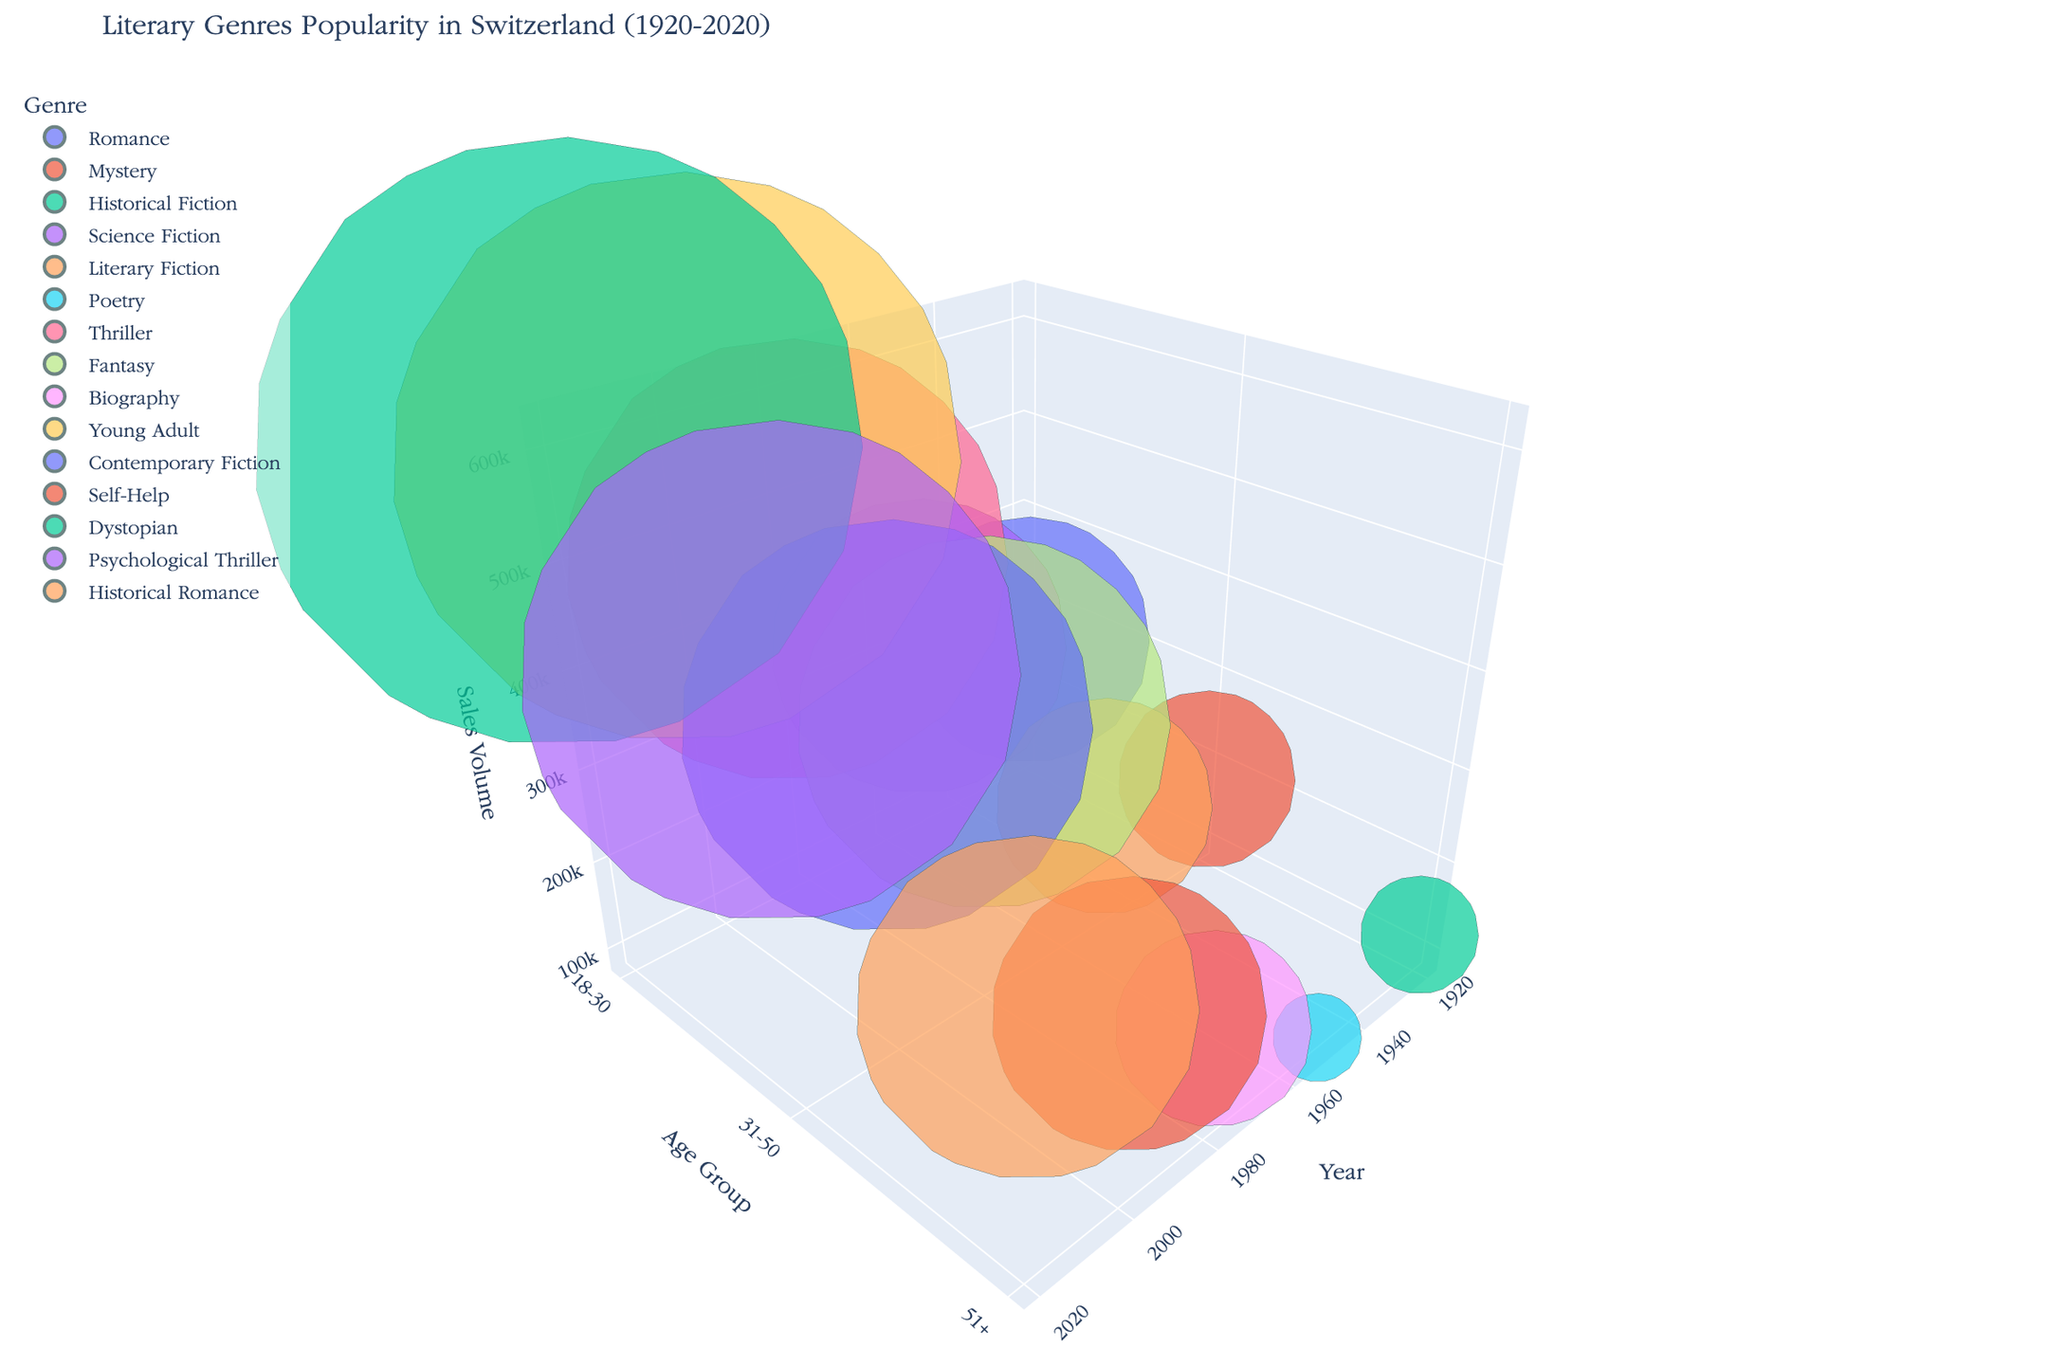what is the title of the chart? The title of the chart is usually displayed at the top of the figure. Reading it from the top of the plot shows "Literary Genres Popularity in Switzerland (1920-2020)".
Answer: Literary Genres Popularity in Switzerland (1920-2020) Which genre has the highest sales volume in the year 1920? Look at the x-axis for the year 1920 and compare the sizes of the bubbles to determine the largest one. The largest bubble in 1920 represents the genre "Romance" with a sales volume of 250,000.
Answer: Romance What was the most popular genre among the 18-30 age group in 1980? Check the y-axis for the age group 18-30 in the year 1980 and identify the size of the bubbles. The largest bubble indicates that the most popular genre was "Thriller" with a sales volume of 450,000.
Answer: Thriller Compare the sales volumes of the Thriller and Fantasy genres in 1980, which genre had higher sales? Find the corresponding bubbles for Thriller and Fantasy in the year 1980, and compare their sizes. The Thriller bubble is larger with a sales volume of 450,000 compared to Fantasy's 380,000.
Answer: Thriller What is the total sales volume for all the 31-50 age group genres in 2000? Identify the bubbles corresponding to the 31-50 age group in the year 2000. The genres are Contemporary Fiction with 420,000 and sum these volumes. The sum is 420,000.
Answer: 420,000 Which year had the highest total sales volume for the 18-30 age group? Compare the sizes of bubbles for the 18-30 age groups across all years. The year with the largest total sales volume appears to be 2020 with Dystopian's bubble showing 620,000.
Answer: 2020 Is the sales trend for the 51+ age group increasing or decreasing from 1920 to 2020? Evaluate the bubbles representing 51+ genres from 1920 to 2020. Start with Historical Fiction in 1920 (120,000), Poetry in 1950 (90,000), Biography in 1980 (200,000), Self-Help in 2000 (280,000), and Historical Romance in 2020 (350,000). The sales volumes indicate an increasing trend.
Answer: Increasing What genre has the smallest sales volume in the year 1950 and what's the value? Locate 1950 on the x-axis, and identify the smallest bubble. The smallest bubble size corresponds to the genre "Poetry" with a sales volume of 90,000.
Answer: Poetry, 90,000 In 2020, which age group has the highest sales volume and for which genre? Examine the bubbles in 2020 and compare their sizes across different age groups. The largest bubble is for the 18-30 age group representing the genre "Dystopian" with a sales volume of 620,000.
Answer: 18-30, Dystopian 